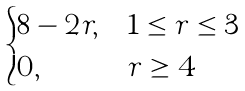<formula> <loc_0><loc_0><loc_500><loc_500>\begin{cases} 8 - 2 r , & 1 \leq r \leq 3 \\ 0 , & r \geq 4 \end{cases}</formula> 